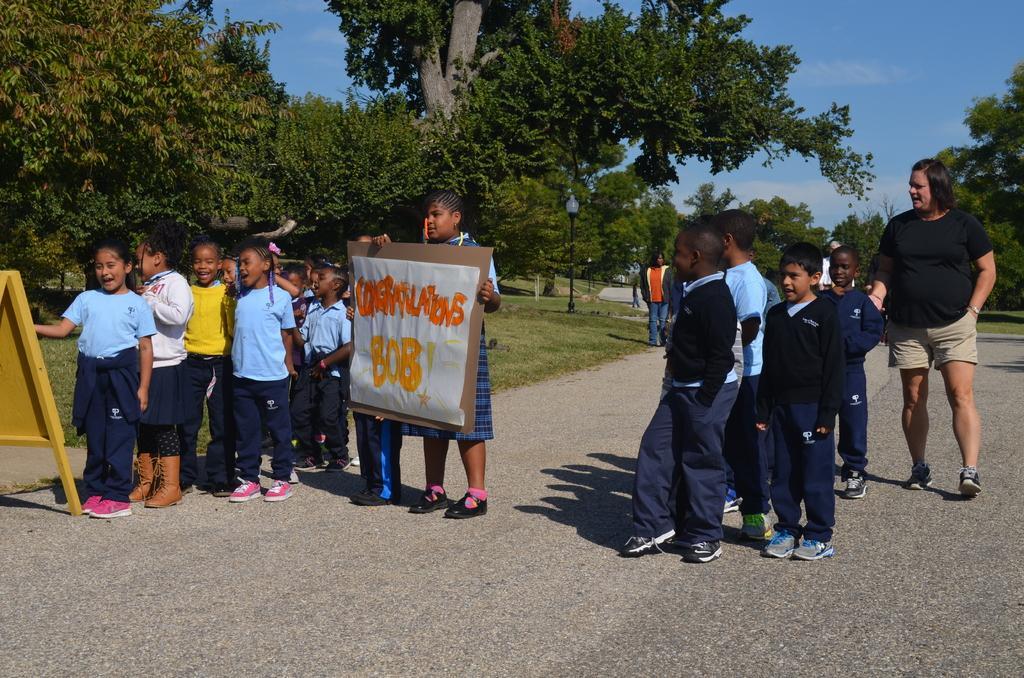Can you describe this image briefly? Children are standing on the road. The person at the center is holding a chart paper. There is a yellow board at the left. The person at the right is wearing a black t shirt and shorts. There are other people behind them. There is a light pole and trees at the back. 